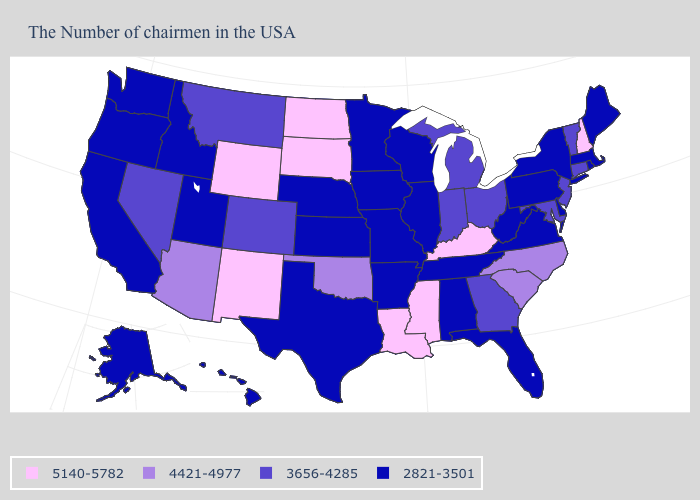Name the states that have a value in the range 2821-3501?
Answer briefly. Maine, Massachusetts, Rhode Island, New York, Delaware, Pennsylvania, Virginia, West Virginia, Florida, Alabama, Tennessee, Wisconsin, Illinois, Missouri, Arkansas, Minnesota, Iowa, Kansas, Nebraska, Texas, Utah, Idaho, California, Washington, Oregon, Alaska, Hawaii. Which states hav the highest value in the MidWest?
Short answer required. South Dakota, North Dakota. Which states have the lowest value in the USA?
Answer briefly. Maine, Massachusetts, Rhode Island, New York, Delaware, Pennsylvania, Virginia, West Virginia, Florida, Alabama, Tennessee, Wisconsin, Illinois, Missouri, Arkansas, Minnesota, Iowa, Kansas, Nebraska, Texas, Utah, Idaho, California, Washington, Oregon, Alaska, Hawaii. What is the value of Idaho?
Quick response, please. 2821-3501. Does the first symbol in the legend represent the smallest category?
Write a very short answer. No. Does Idaho have a higher value than West Virginia?
Keep it brief. No. Which states have the lowest value in the MidWest?
Quick response, please. Wisconsin, Illinois, Missouri, Minnesota, Iowa, Kansas, Nebraska. What is the value of New Mexico?
Quick response, please. 5140-5782. What is the lowest value in the Northeast?
Answer briefly. 2821-3501. What is the lowest value in the MidWest?
Concise answer only. 2821-3501. What is the value of Idaho?
Keep it brief. 2821-3501. Among the states that border Tennessee , does Mississippi have the highest value?
Write a very short answer. Yes. Does the map have missing data?
Concise answer only. No. Name the states that have a value in the range 5140-5782?
Write a very short answer. New Hampshire, Kentucky, Mississippi, Louisiana, South Dakota, North Dakota, Wyoming, New Mexico. Does Massachusetts have a lower value than Ohio?
Concise answer only. Yes. 